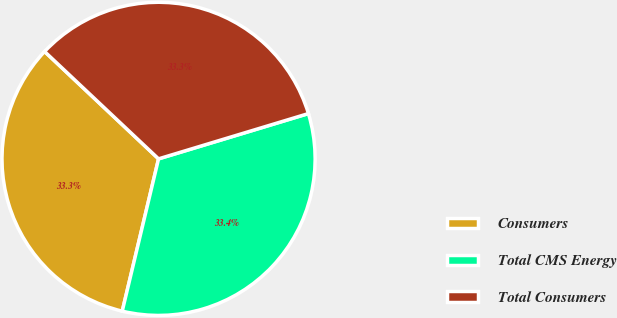Convert chart to OTSL. <chart><loc_0><loc_0><loc_500><loc_500><pie_chart><fcel>Consumers<fcel>Total CMS Energy<fcel>Total Consumers<nl><fcel>33.3%<fcel>33.4%<fcel>33.31%<nl></chart> 